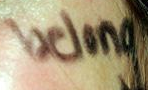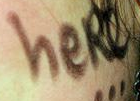What words can you see in these images in sequence, separated by a semicolon? belong; heRe 